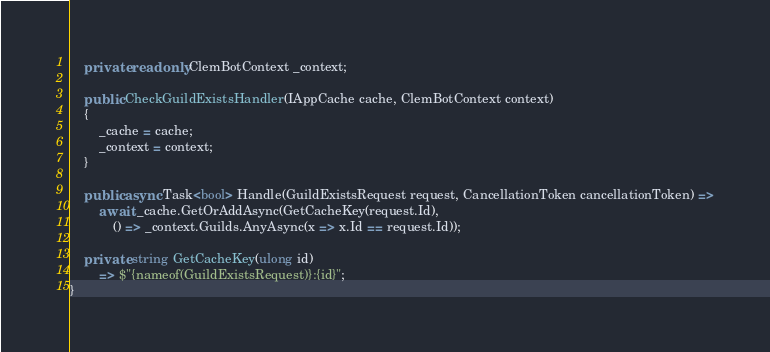Convert code to text. <code><loc_0><loc_0><loc_500><loc_500><_C#_>    private readonly ClemBotContext _context;

    public CheckGuildExistsHandler(IAppCache cache, ClemBotContext context)
    {
        _cache = cache;
        _context = context;
    }

    public async Task<bool> Handle(GuildExistsRequest request, CancellationToken cancellationToken) =>
        await _cache.GetOrAddAsync(GetCacheKey(request.Id),
            () => _context.Guilds.AnyAsync(x => x.Id == request.Id));

    private string GetCacheKey(ulong id)
        => $"{nameof(GuildExistsRequest)}:{id}";
}</code> 